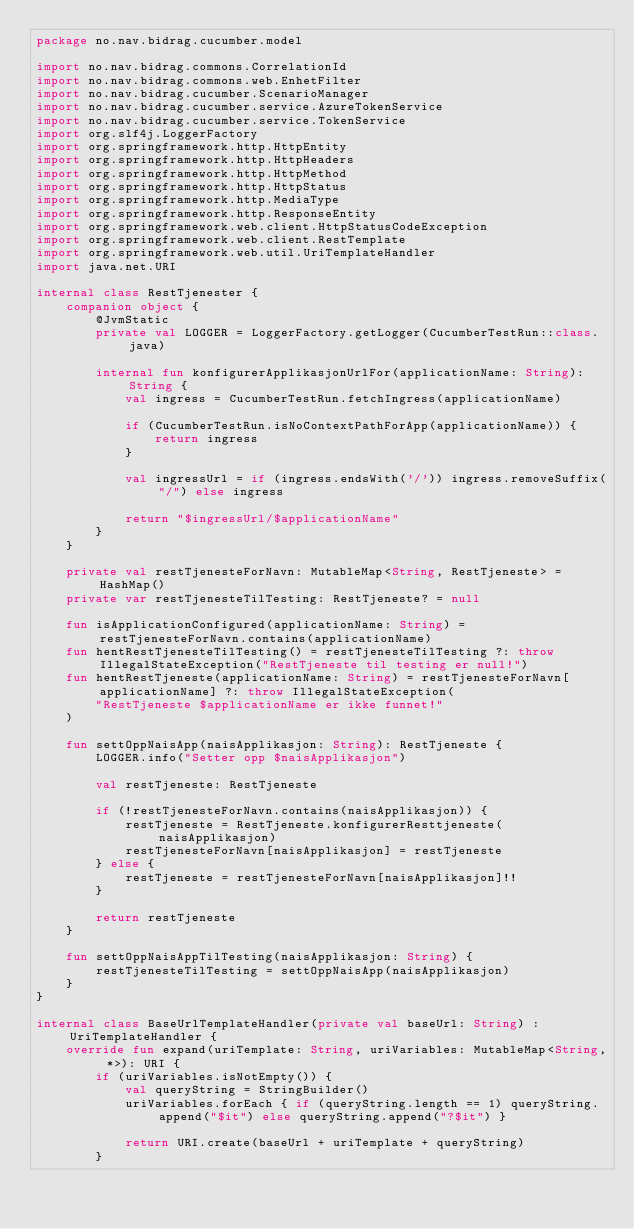<code> <loc_0><loc_0><loc_500><loc_500><_Kotlin_>package no.nav.bidrag.cucumber.model

import no.nav.bidrag.commons.CorrelationId
import no.nav.bidrag.commons.web.EnhetFilter
import no.nav.bidrag.cucumber.ScenarioManager
import no.nav.bidrag.cucumber.service.AzureTokenService
import no.nav.bidrag.cucumber.service.TokenService
import org.slf4j.LoggerFactory
import org.springframework.http.HttpEntity
import org.springframework.http.HttpHeaders
import org.springframework.http.HttpMethod
import org.springframework.http.HttpStatus
import org.springframework.http.MediaType
import org.springframework.http.ResponseEntity
import org.springframework.web.client.HttpStatusCodeException
import org.springframework.web.client.RestTemplate
import org.springframework.web.util.UriTemplateHandler
import java.net.URI

internal class RestTjenester {
    companion object {
        @JvmStatic
        private val LOGGER = LoggerFactory.getLogger(CucumberTestRun::class.java)

        internal fun konfigurerApplikasjonUrlFor(applicationName: String): String {
            val ingress = CucumberTestRun.fetchIngress(applicationName)

            if (CucumberTestRun.isNoContextPathForApp(applicationName)) {
                return ingress
            }

            val ingressUrl = if (ingress.endsWith('/')) ingress.removeSuffix("/") else ingress

            return "$ingressUrl/$applicationName"
        }
    }

    private val restTjenesteForNavn: MutableMap<String, RestTjeneste> = HashMap()
    private var restTjenesteTilTesting: RestTjeneste? = null

    fun isApplicationConfigured(applicationName: String) = restTjenesteForNavn.contains(applicationName)
    fun hentRestTjenesteTilTesting() = restTjenesteTilTesting ?: throw IllegalStateException("RestTjeneste til testing er null!")
    fun hentRestTjeneste(applicationName: String) = restTjenesteForNavn[applicationName] ?: throw IllegalStateException(
        "RestTjeneste $applicationName er ikke funnet!"
    )

    fun settOppNaisApp(naisApplikasjon: String): RestTjeneste {
        LOGGER.info("Setter opp $naisApplikasjon")

        val restTjeneste: RestTjeneste

        if (!restTjenesteForNavn.contains(naisApplikasjon)) {
            restTjeneste = RestTjeneste.konfigurerResttjeneste(naisApplikasjon)
            restTjenesteForNavn[naisApplikasjon] = restTjeneste
        } else {
            restTjeneste = restTjenesteForNavn[naisApplikasjon]!!
        }

        return restTjeneste
    }

    fun settOppNaisAppTilTesting(naisApplikasjon: String) {
        restTjenesteTilTesting = settOppNaisApp(naisApplikasjon)
    }
}

internal class BaseUrlTemplateHandler(private val baseUrl: String) : UriTemplateHandler {
    override fun expand(uriTemplate: String, uriVariables: MutableMap<String, *>): URI {
        if (uriVariables.isNotEmpty()) {
            val queryString = StringBuilder()
            uriVariables.forEach { if (queryString.length == 1) queryString.append("$it") else queryString.append("?$it") }

            return URI.create(baseUrl + uriTemplate + queryString)
        }
</code> 